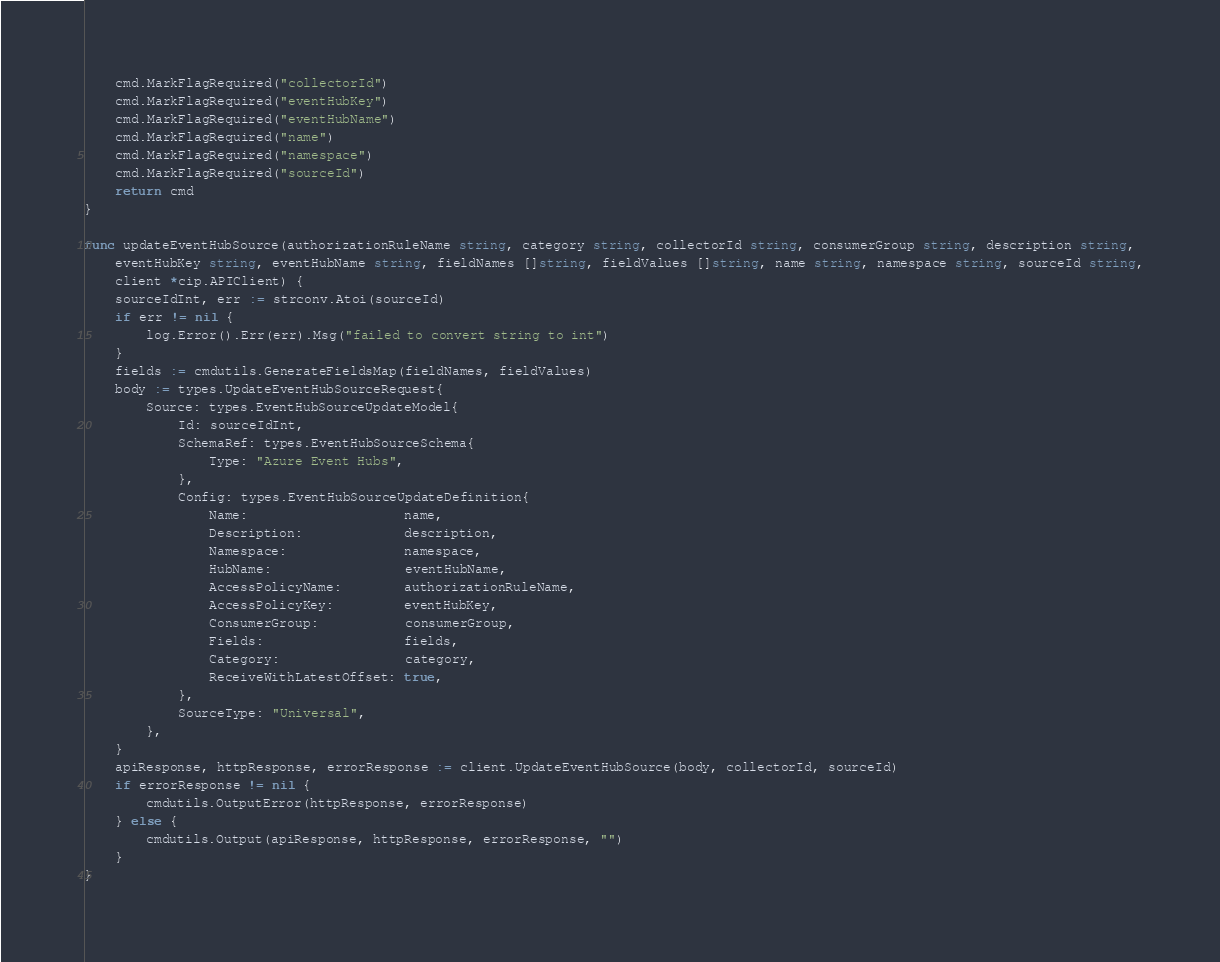Convert code to text. <code><loc_0><loc_0><loc_500><loc_500><_Go_>	cmd.MarkFlagRequired("collectorId")
	cmd.MarkFlagRequired("eventHubKey")
	cmd.MarkFlagRequired("eventHubName")
	cmd.MarkFlagRequired("name")
	cmd.MarkFlagRequired("namespace")
	cmd.MarkFlagRequired("sourceId")
	return cmd
}

func updateEventHubSource(authorizationRuleName string, category string, collectorId string, consumerGroup string, description string,
	eventHubKey string, eventHubName string, fieldNames []string, fieldValues []string, name string, namespace string, sourceId string,
	client *cip.APIClient) {
	sourceIdInt, err := strconv.Atoi(sourceId)
	if err != nil {
		log.Error().Err(err).Msg("failed to convert string to int")
	}
	fields := cmdutils.GenerateFieldsMap(fieldNames, fieldValues)
	body := types.UpdateEventHubSourceRequest{
		Source: types.EventHubSourceUpdateModel{
			Id: sourceIdInt,
			SchemaRef: types.EventHubSourceSchema{
				Type: "Azure Event Hubs",
			},
			Config: types.EventHubSourceUpdateDefinition{
				Name:                    name,
				Description:             description,
				Namespace:               namespace,
				HubName:                 eventHubName,
				AccessPolicyName:        authorizationRuleName,
				AccessPolicyKey:         eventHubKey,
				ConsumerGroup:           consumerGroup,
				Fields:                  fields,
				Category:                category,
				ReceiveWithLatestOffset: true,
			},
			SourceType: "Universal",
		},
	}
	apiResponse, httpResponse, errorResponse := client.UpdateEventHubSource(body, collectorId, sourceId)
	if errorResponse != nil {
		cmdutils.OutputError(httpResponse, errorResponse)
	} else {
		cmdutils.Output(apiResponse, httpResponse, errorResponse, "")
	}
}
</code> 